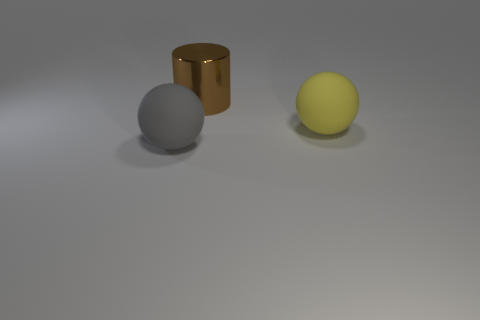Can you describe the lighting in the scene? The lighting in the scene is soft and diffused, coming from above, casting gentle shadows beneath the objects on the ground. Does the lighting affect the color of the objects? Yes, the lighting gives the objects a slight highlight at the top, making their colors appear more vivid, while the shadows create a sense of depth and volume. 